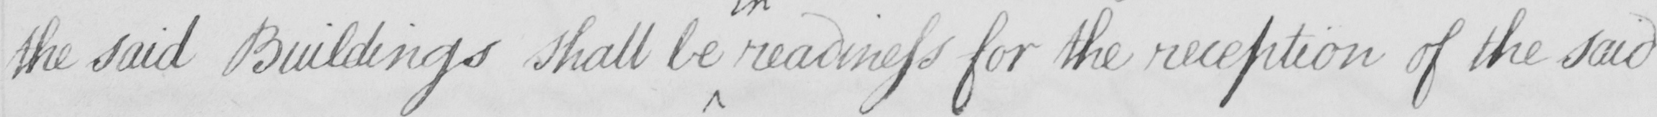What text is written in this handwritten line? the said Buildings shall be readiness for the reception of the said 